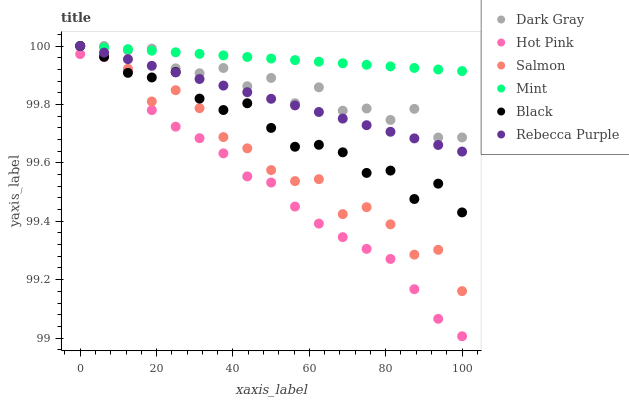Does Hot Pink have the minimum area under the curve?
Answer yes or no. Yes. Does Mint have the maximum area under the curve?
Answer yes or no. Yes. Does Salmon have the minimum area under the curve?
Answer yes or no. No. Does Salmon have the maximum area under the curve?
Answer yes or no. No. Is Rebecca Purple the smoothest?
Answer yes or no. Yes. Is Salmon the roughest?
Answer yes or no. Yes. Is Dark Gray the smoothest?
Answer yes or no. No. Is Dark Gray the roughest?
Answer yes or no. No. Does Hot Pink have the lowest value?
Answer yes or no. Yes. Does Salmon have the lowest value?
Answer yes or no. No. Does Mint have the highest value?
Answer yes or no. Yes. Is Hot Pink less than Rebecca Purple?
Answer yes or no. Yes. Is Salmon greater than Hot Pink?
Answer yes or no. Yes. Does Mint intersect Dark Gray?
Answer yes or no. Yes. Is Mint less than Dark Gray?
Answer yes or no. No. Is Mint greater than Dark Gray?
Answer yes or no. No. Does Hot Pink intersect Rebecca Purple?
Answer yes or no. No. 